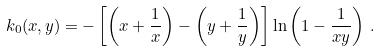<formula> <loc_0><loc_0><loc_500><loc_500>k _ { 0 } ( x , y ) = - \left [ \left ( x + \frac { 1 } { x } \right ) - \left ( y + \frac { 1 } { y } \right ) \right ] \ln \left ( 1 - \frac { 1 } { x y } \right ) \, .</formula> 